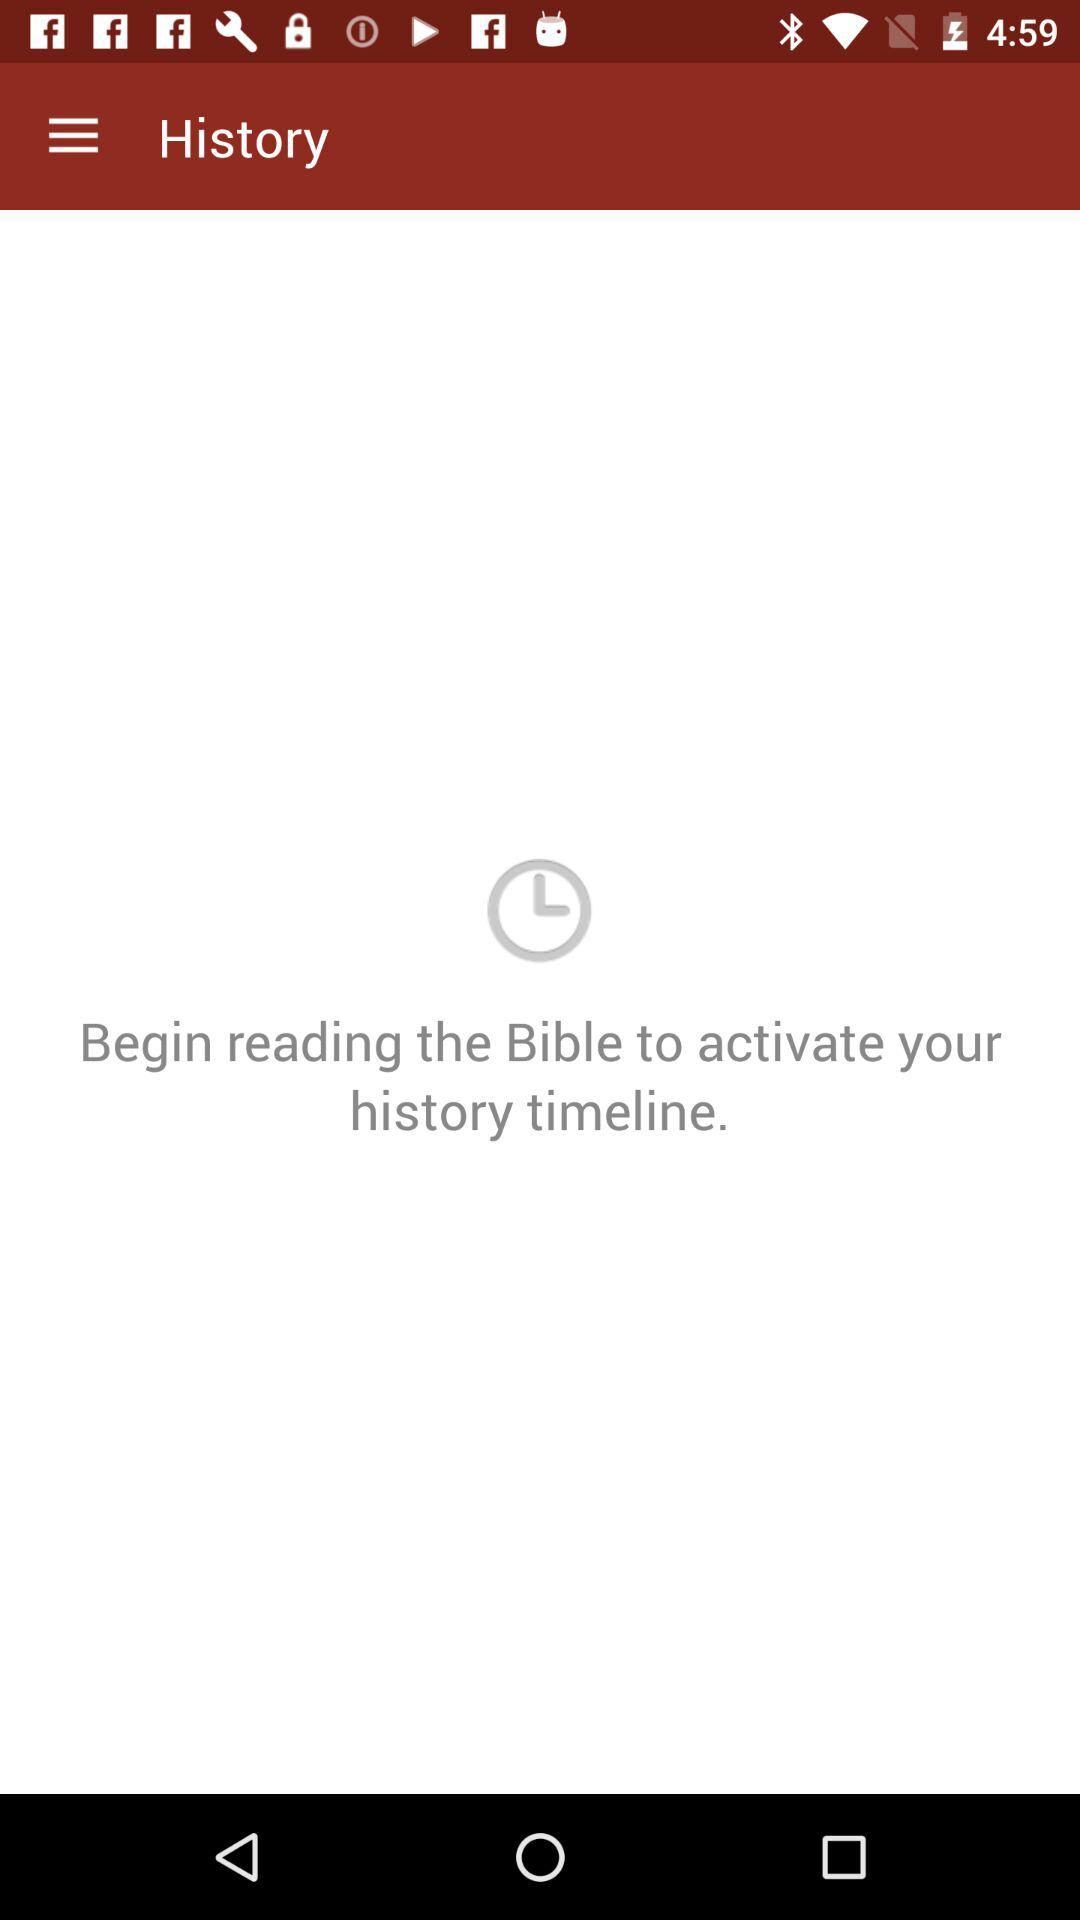How can we activate the history timeline? You can activate the history timeline by beginning to read the Bible. 